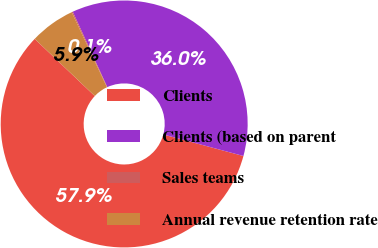Convert chart to OTSL. <chart><loc_0><loc_0><loc_500><loc_500><pie_chart><fcel>Clients<fcel>Clients (based on parent<fcel>Sales teams<fcel>Annual revenue retention rate<nl><fcel>57.92%<fcel>36.02%<fcel>0.14%<fcel>5.92%<nl></chart> 